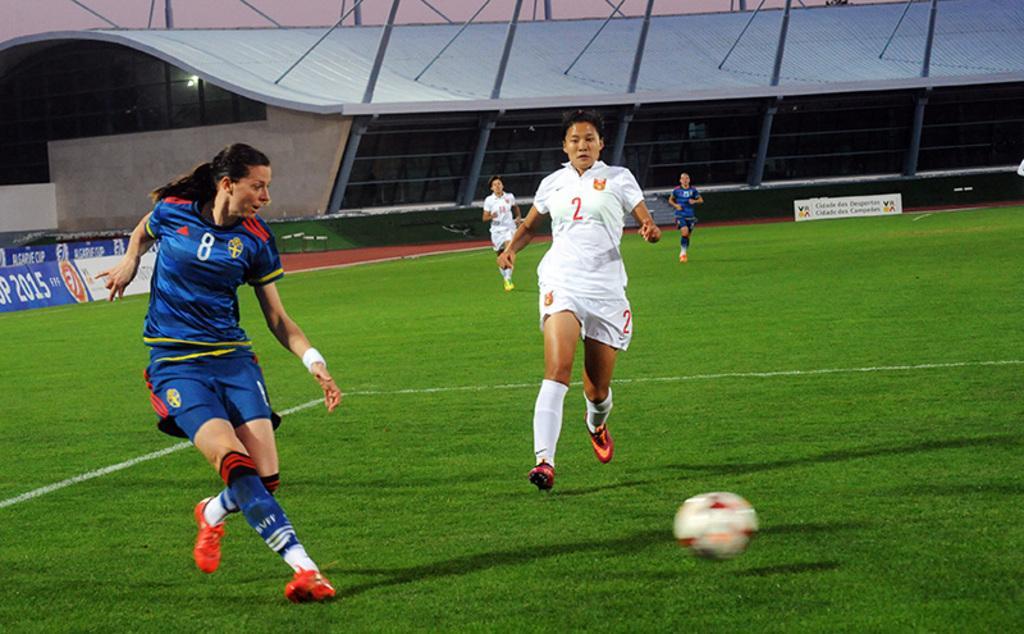In one or two sentences, can you explain what this image depicts? In this picture we can see people on the ground, here we can see a ball and in the background we can see advertisement boards, shed and some objects. 